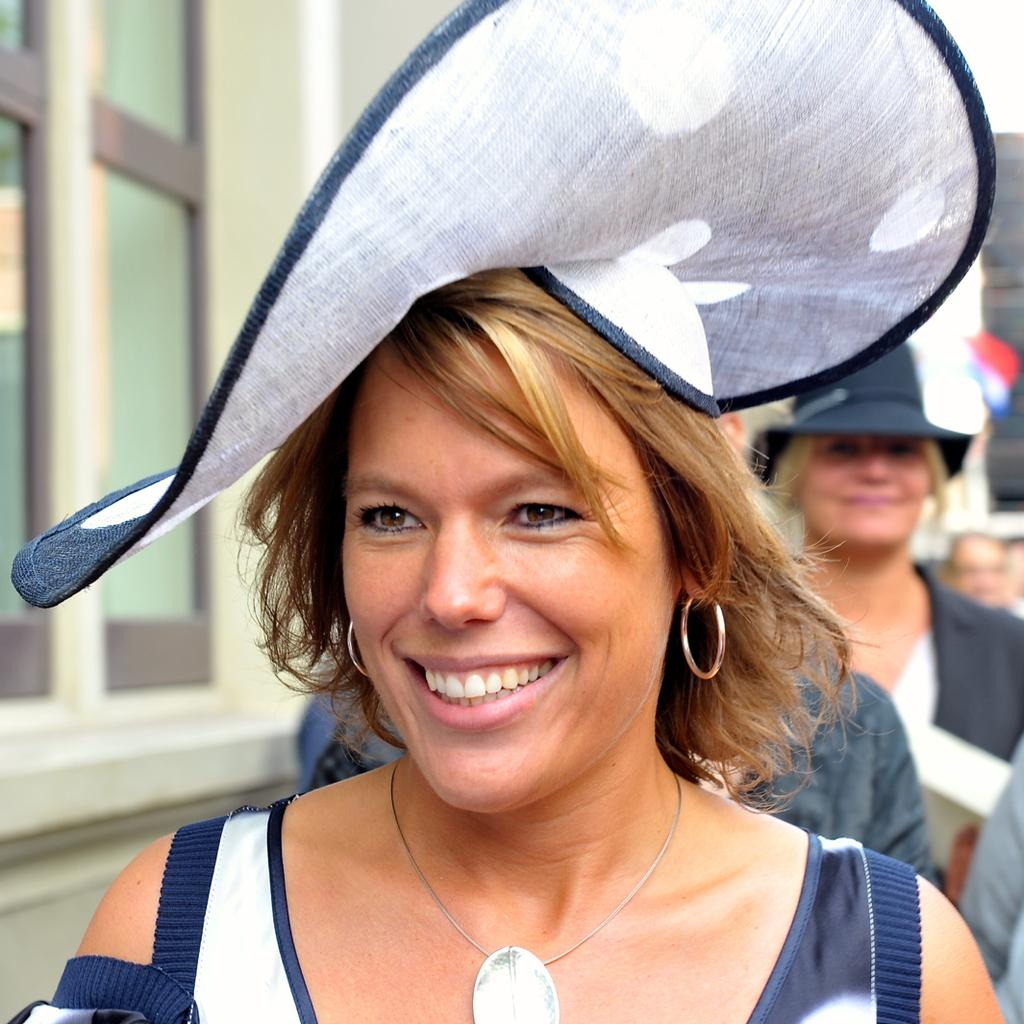Who is the main subject in the image? There is a woman in the image. What is the woman wearing on her head? The woman is wearing a hat. What is the woman's facial expression in the image? The woman is smiling. Can you describe the background of the image? There are blurred people behind the woman, and there is a window on the left side of the woman. What type of punishment is being administered to the woman in the image? There is no indication of punishment in the image; the woman is smiling and wearing a hat. How is the division of labor represented in the image? The image does not depict any labor or division of labor; it features a woman wearing a hat and smiling. 